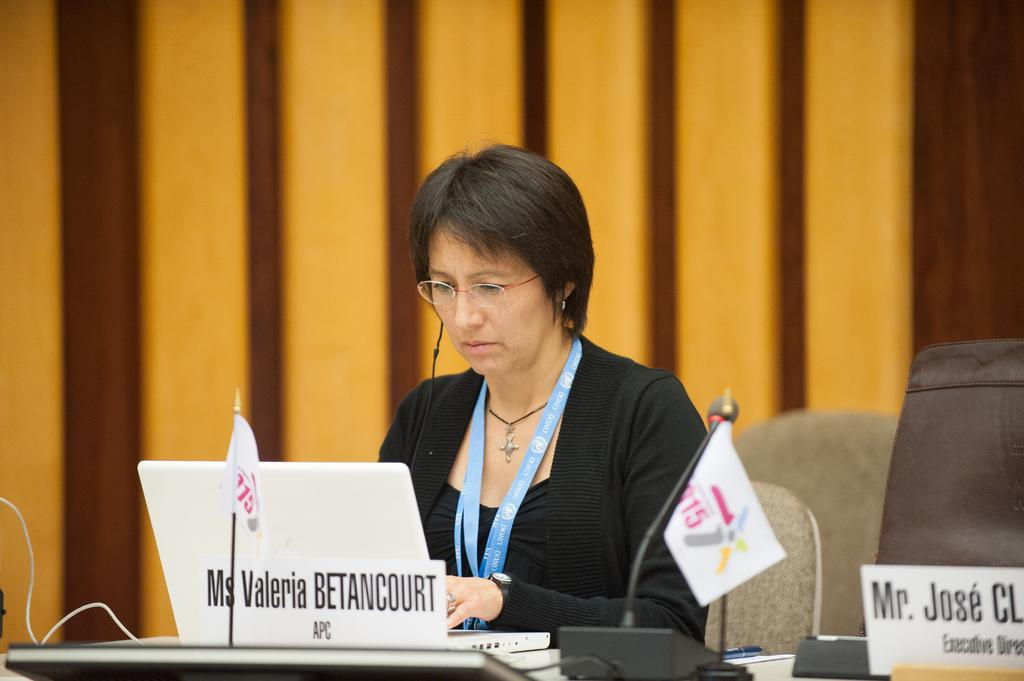What is the woman in the image doing? The woman is sitting in the image. Can you describe what the woman is wearing? The woman is wearing a tag. What objects can be seen in the image related to communication or presentations? Name boards, a microphone, and a laptop are present in the image. What can be seen in the image that represents a country or organization? Flags are visible in the image. What is on the table in the image? There are objects on a table in the image. What is the background of the image? The background of the image includes a wall. What type of linen is draped over the woman's chair in the image? There is no linen draped over the woman's chair in the image. How does the bell ring during the presentation in the image? There is no bell present in the image. 